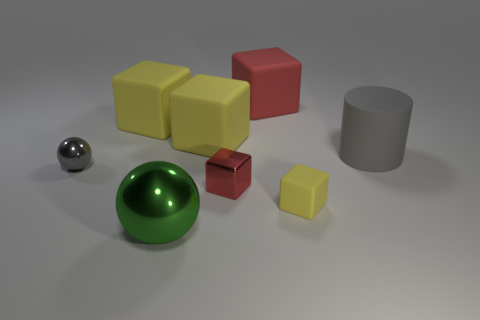Subtract all metallic blocks. How many blocks are left? 4 Add 1 big yellow rubber things. How many objects exist? 9 Subtract all cubes. How many objects are left? 3 Subtract all brown cubes. How many cyan spheres are left? 0 Subtract all tiny gray things. Subtract all red matte things. How many objects are left? 6 Add 2 small red blocks. How many small red blocks are left? 3 Add 3 small shiny cubes. How many small shiny cubes exist? 4 Subtract all yellow blocks. How many blocks are left? 2 Subtract 0 yellow spheres. How many objects are left? 8 Subtract 3 blocks. How many blocks are left? 2 